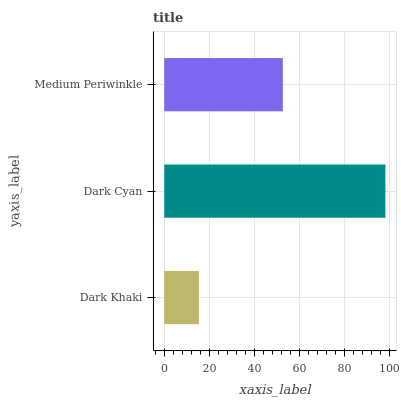Is Dark Khaki the minimum?
Answer yes or no. Yes. Is Dark Cyan the maximum?
Answer yes or no. Yes. Is Medium Periwinkle the minimum?
Answer yes or no. No. Is Medium Periwinkle the maximum?
Answer yes or no. No. Is Dark Cyan greater than Medium Periwinkle?
Answer yes or no. Yes. Is Medium Periwinkle less than Dark Cyan?
Answer yes or no. Yes. Is Medium Periwinkle greater than Dark Cyan?
Answer yes or no. No. Is Dark Cyan less than Medium Periwinkle?
Answer yes or no. No. Is Medium Periwinkle the high median?
Answer yes or no. Yes. Is Medium Periwinkle the low median?
Answer yes or no. Yes. Is Dark Khaki the high median?
Answer yes or no. No. Is Dark Cyan the low median?
Answer yes or no. No. 